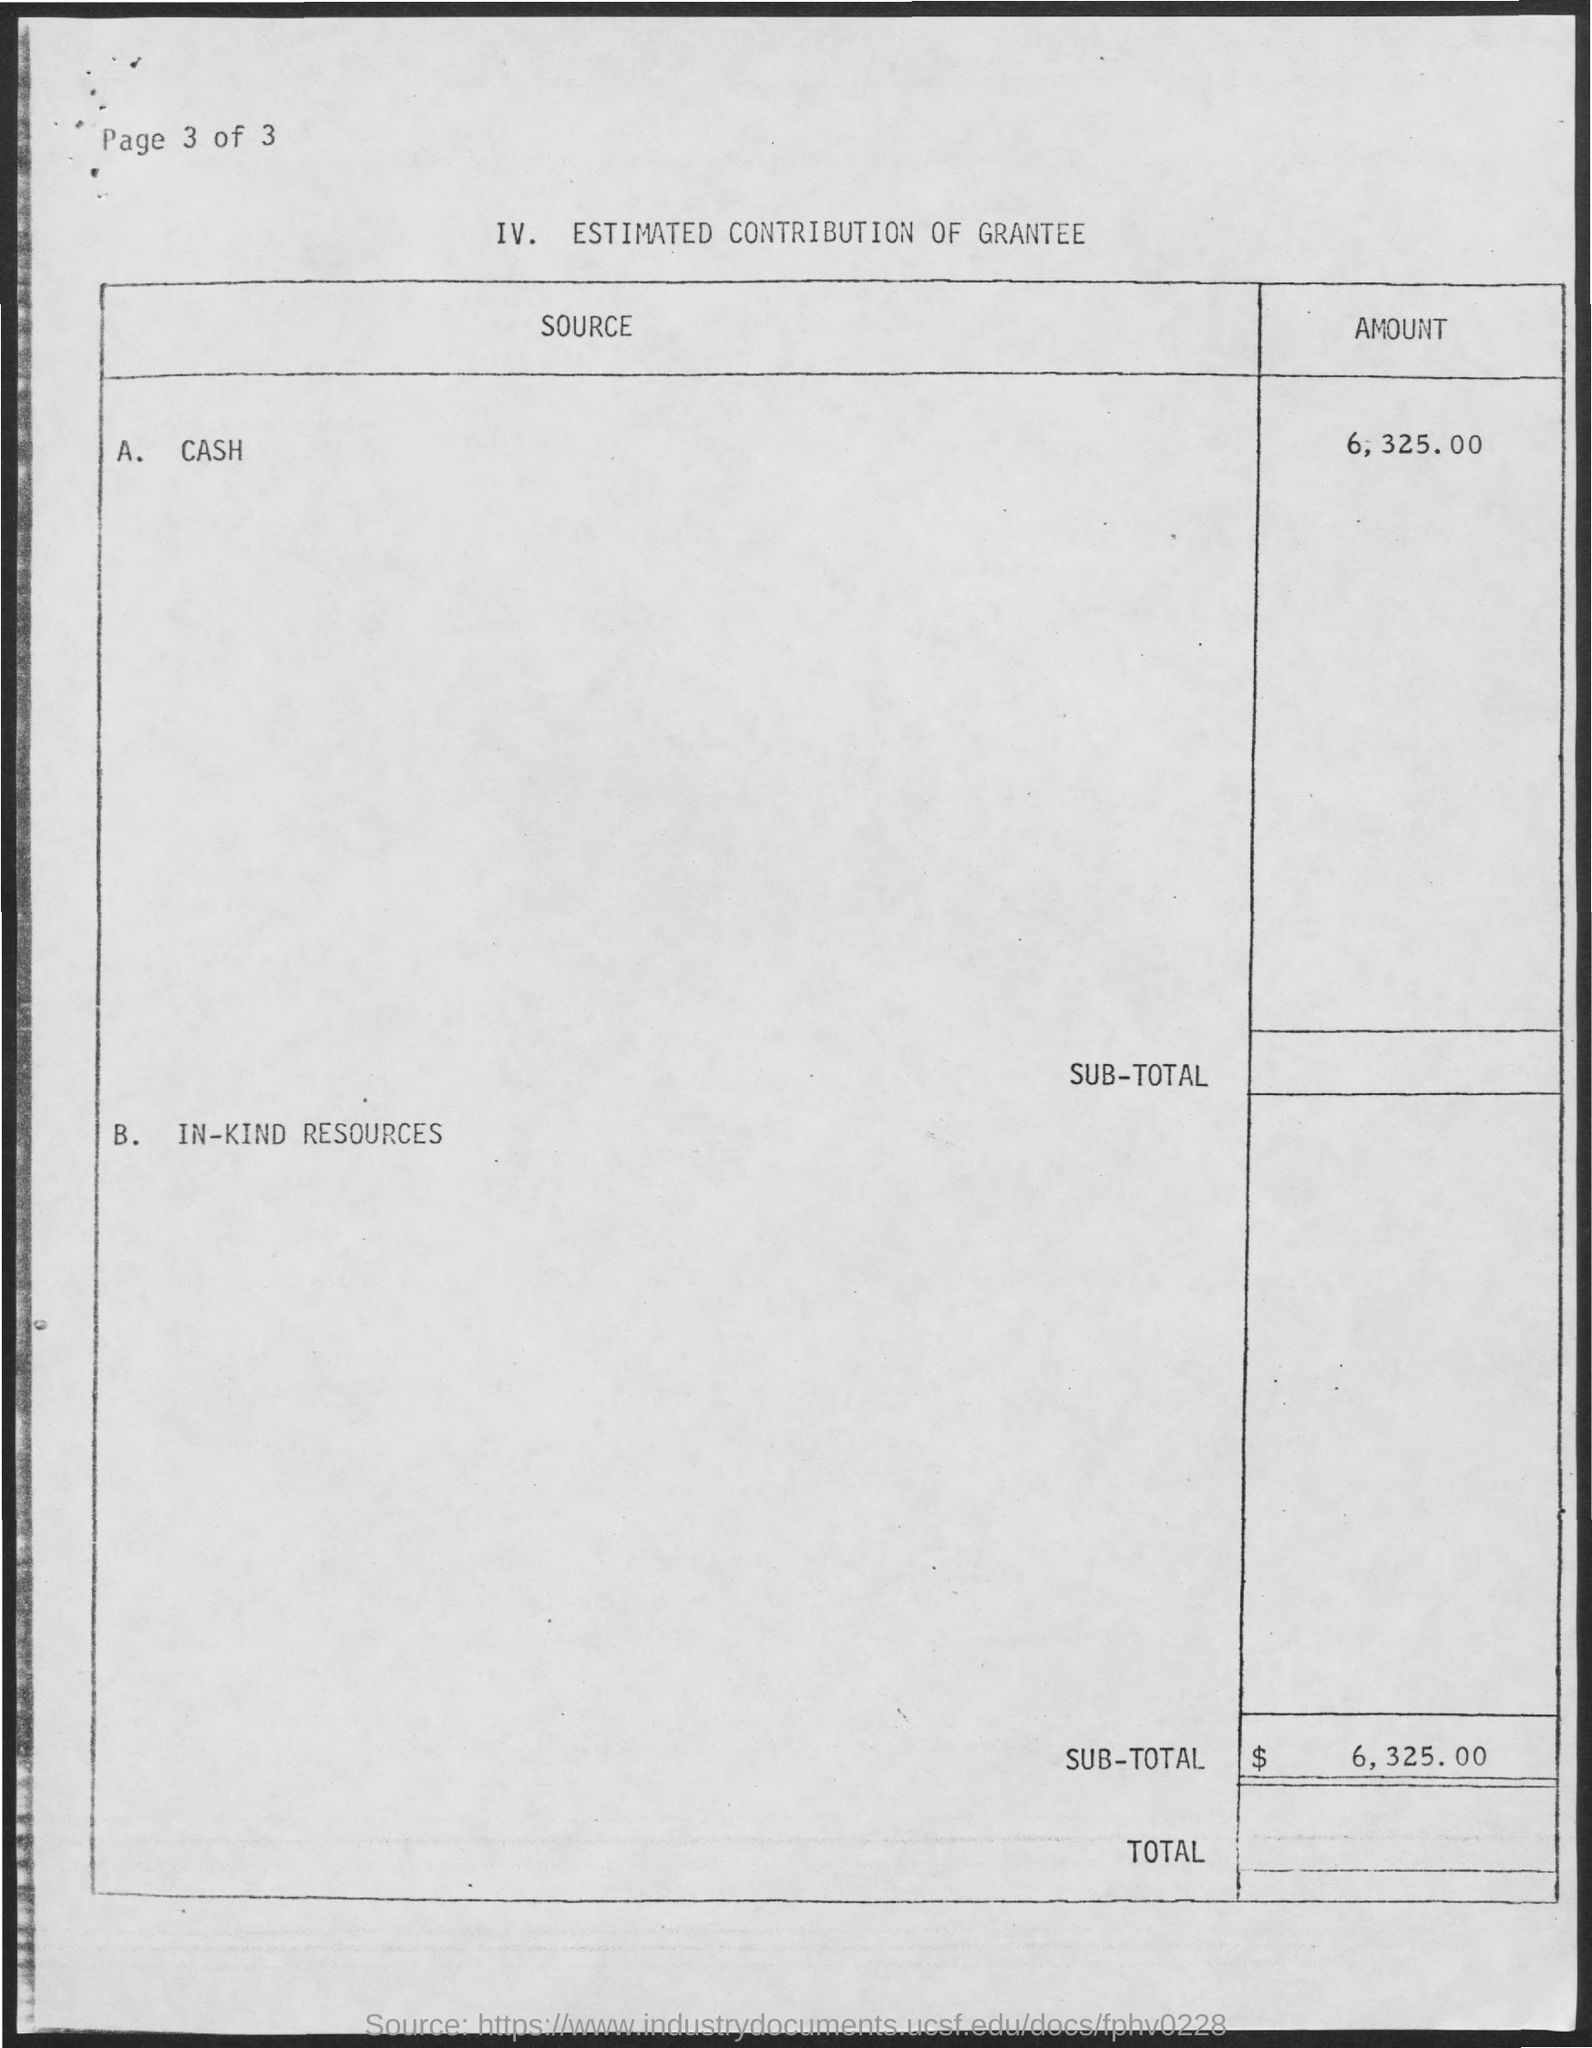Specify some key components in this picture. The page number located at the left top of the page is 3. What is the heading of the first column of the table? The amount given for cash is 6,325.00. The first entry in the "SOURCE" column should read "cash. The second entry under the "SOURCE" column is "B. IN-KIND RESOURCES. 